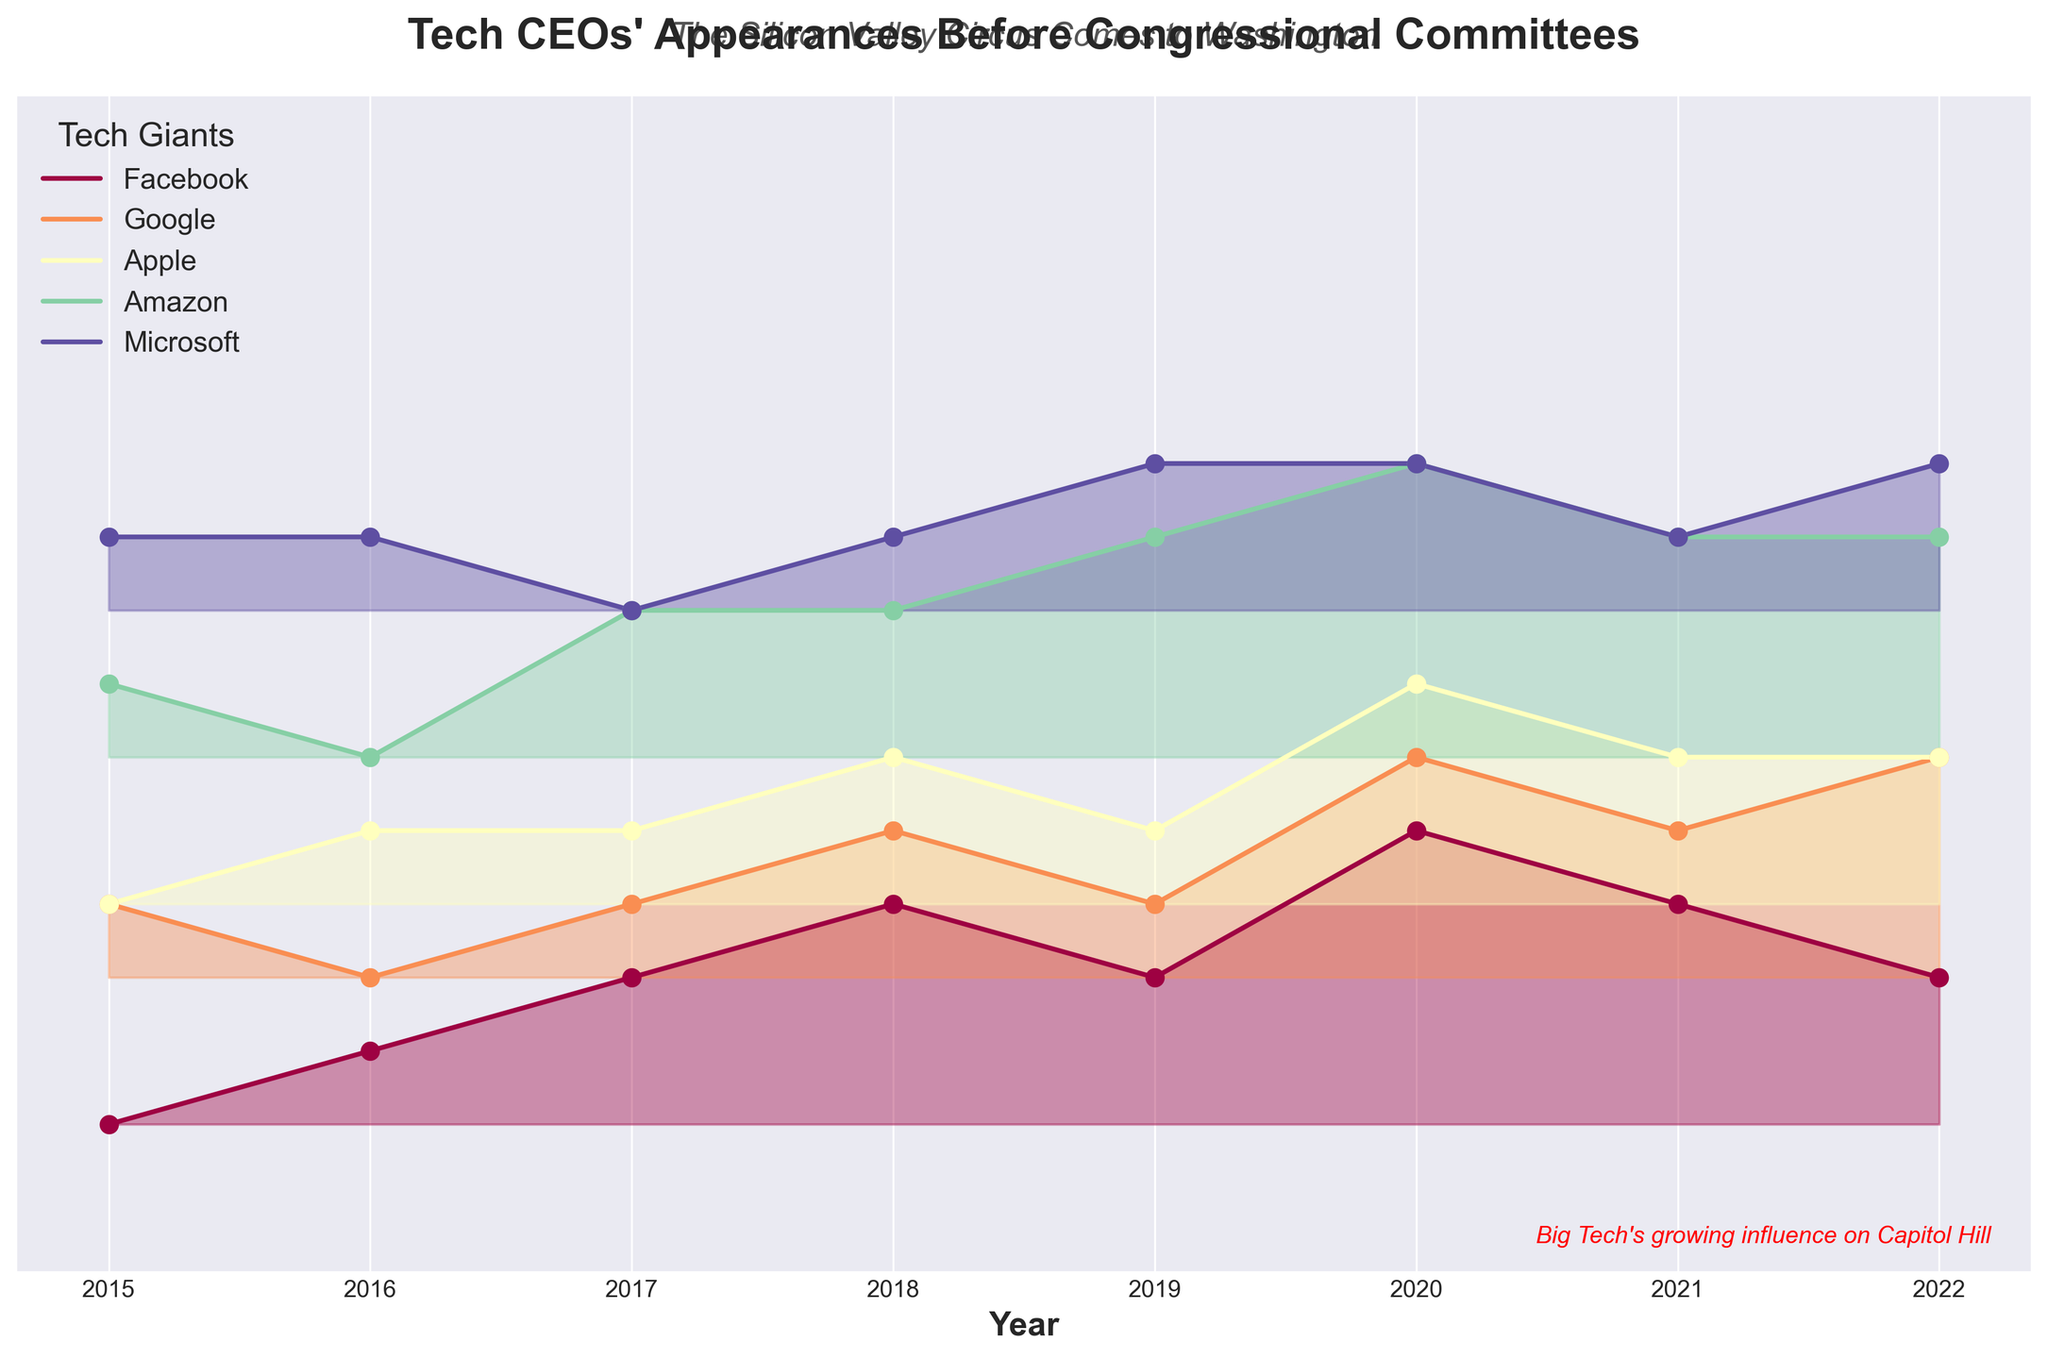What's the title of the plot? The title is usually displayed at the top of the plot. In this case, the title is "Tech CEOs' Appearances Before Congressional Committees".
Answer: Tech CEOs' Appearances Before Congressional Committees Which company had the highest number of appearances in 2020? By observing the plot's curves for the year 2020, we can see that the curve for Google reaches the highest y-value.
Answer: Google How many appearances did Facebook's CEO make in 2021? For Facebook in 2021, the y-value directly represents the number of appearances, which is indicated by the marked points on the line.
Answer: 4 Which years did Microsoft CEOs appear before congressional committees more frequently than Apple CEOs? Observing the respective heights of Microsoft's and Apple's curves for each year, Microsoft has higher y-values than Apple in 2019 and 2022.
Answer: 2019, 2022 What is the average number of appearances for Amazon's CEO over the years shown? Sum the number of appearances for Amazon (1+3+2+4+3+3+2) and divide by the total number of years (8). The sum is 18, and averaging it gives 18/8.
Answer: 2.25 Which company had the least increase in appearances over time? By examining each company's curve for changes from starting to ending year, Microsoft’s curve has the smallest vertical change from 2015 to 2022.
Answer: Microsoft Which year saw the highest total number of appearances by all Tech CEOs combined? By summing the y-values for each company in each year: 2015 (5), 2016 (5), 2017 (8), 2018 (12), 2019 (11), 2020 (18), 2021 (13), 2022 (14). The highest is 2020.
Answer: 2020 When did Facebook and Amazon have the same number of appearances? Check each year to see where the y-values for Facebook and Amazon intersect: In 2015 and 2018, both have y-values indicating 1 and 2 appearances respectively.
Answer: 2015, 2018 Which company showed the most inconsistent (fluctuating) trend over the years? Assess the variability of the lines for each company and determine which shows the most ups and downs. Facebook’s line has significant fluctuations over the years compared to others.
Answer: Facebook How many appearances did CEOs make in 2018 and which company had the maximum that year? Summing the y-values for 2018: Facebook (4), Google (3), Apple (2), Amazon (2), Microsoft (1) gives a total of 12. Facebook made the highest appearances that year with 4.
Answer: 12, Facebook 